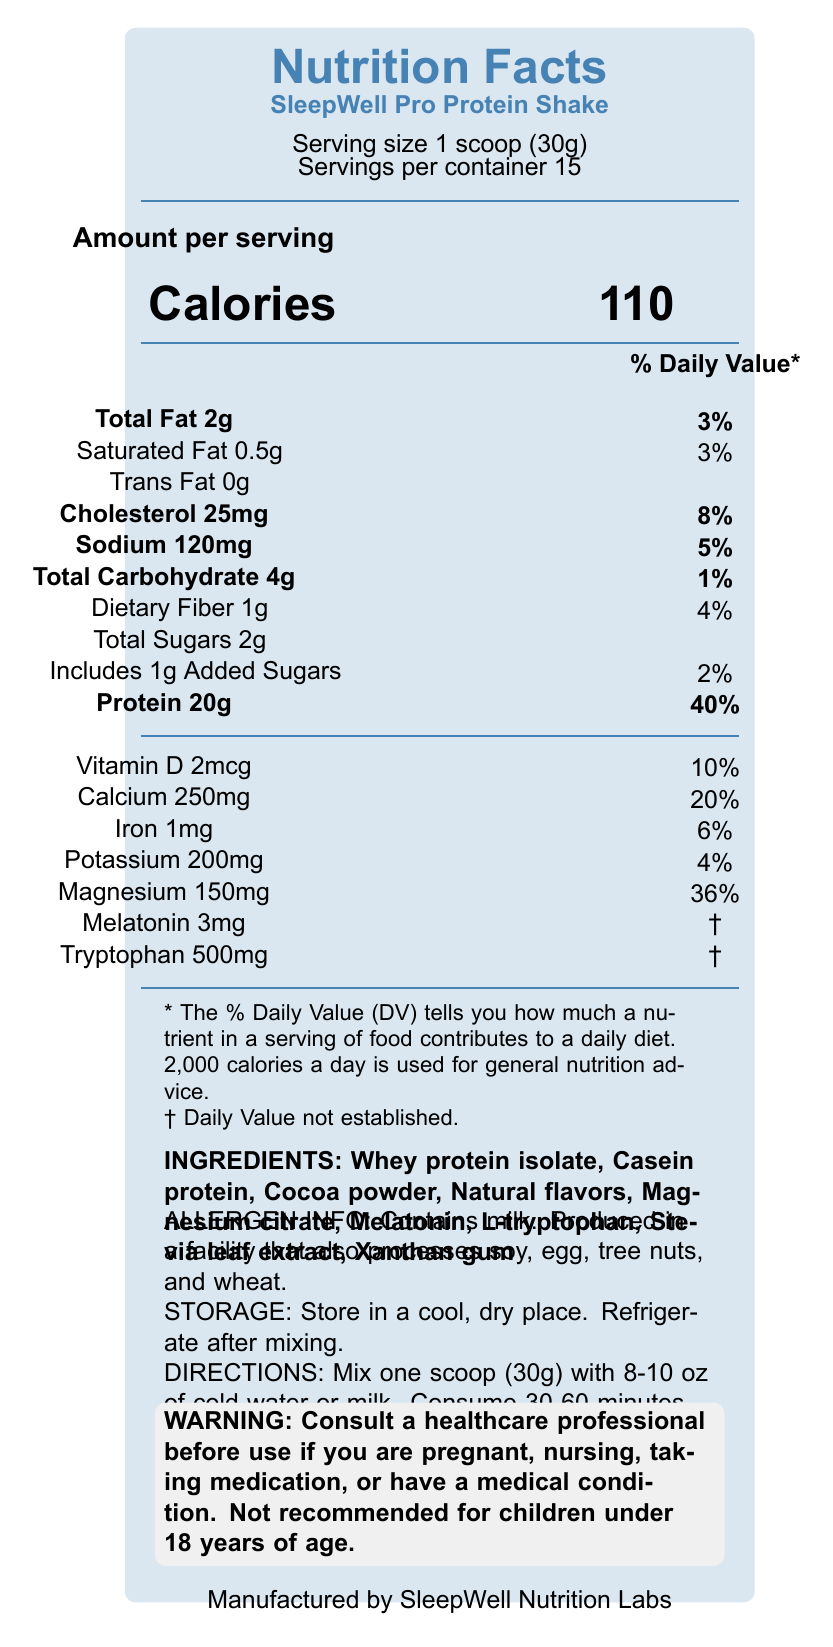what is the serving size of the SleepWell Pro Protein Shake? The serving size is explicitly mentioned in the document as "Serving size 1 scoop (30g)."
Answer: 1 scoop (30g) how many calories are in one serving of the SleepWell Pro Protein Shake? The document lists the calorie content as "Calories: 110."
Answer: 110 what minerals are included in the SleepWell Pro Protein Shake? The minerals listed in the document are Calcium (250mg), Iron (1mg), Potassium (200mg), and Magnesium (150mg).
Answer: Calcium, Iron, Potassium, Magnesium how much melatonin is in each serving of the product? The document lists the melatonin content as "Melatonin 3mg."
Answer: 3mg what is the primary source of protein in this shake? The ingredients list mentions "Whey protein isolate" and "Casein protein" as the primary protein sources.
Answer: Whey protein isolate, Casein protein what percentage of the daily value does 20g of protein represent? A. 20% B. 30% C. 40% The document states "Protein 20g" and "Daily Value 40%," so the correct answer is 40%.
Answer: C. 40% how much sodium does one serving provide? A. 50mg B. 100mg C. 120mg D. 150mg The document states "Sodium 120mg."
Answer: C. 120mg is the SleepWell Pro Protein Shake suitable for people with soy allergies? The allergen info states, "Produced in a facility that also processes soy," indicating potential cross-contamination.
Answer: No does the product contain any added sugars? The document shows "Includes 1g Added Sugars."
Answer: Yes what are the directions for consuming the SleepWell Pro Protein Shake? The directions for consumption are explicitly mentioned in the section labeled "DIRECTIONS."
Answer: Mix one scoop (30g) with 8-10 oz of cold water or milk. Consume 30-60 minutes before bedtime. does the SleepWell Pro Protein Shake contain any cholesterol? The document lists "Cholesterol 25mg" with a daily value of 8%.
Answer: Yes are any % Daily Values not established for certain ingredients? The % Daily Values for Melatonin and Tryptophan are not established, as indicated by "†."
Answer: Yes summarize the main features of the SleepWell Pro Protein Shake. This answer summarizes the document's details about nutritional information, ingredients, intended usage, and warnings, providing a holistic view of the product.
Answer: The SleepWell Pro Protein Shake is a high-protein supplement formulated to support healthy sleep patterns. It contains 110 calories per serving, with 2g of total fat, 4g of carbohydrates, and 20g of protein. Key ingredients include whey protein isolate, casein protein, melatonin, and magnesium. It also provides vitamins and minerals such as Vitamin D, Calcium, Iron, Potassium, and Magnesium. The product is intended to be consumed 30-60 minutes before bedtime to aid in muscle recovery and promote relaxation. It comes with a warning to consult a healthcare professional if pregnant, nursing, or having a medical condition. what scientific evidence supports the main claims of the SleepWell Pro Protein Shake? The document does not provide specific scientific studies or evidence supporting the claims. It only mentions that it is formulated with "evidence-based ingredients."
Answer: Not enough information 